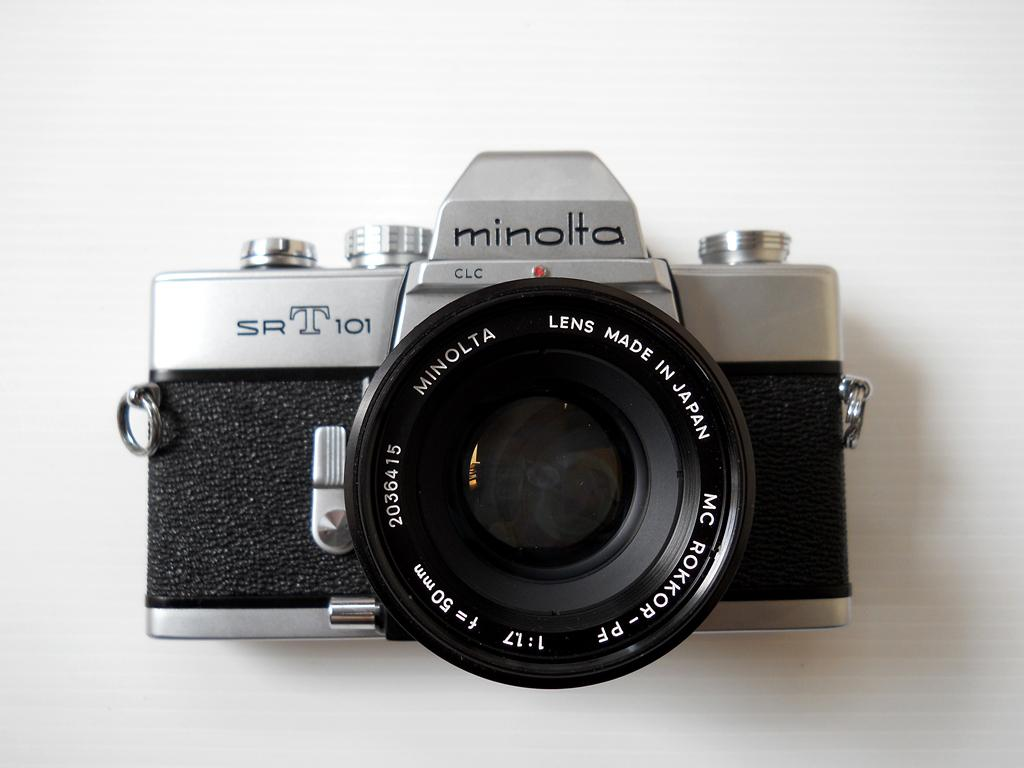<image>
Share a concise interpretation of the image provided. An old fashioned camera with the logo minolta on the top. 